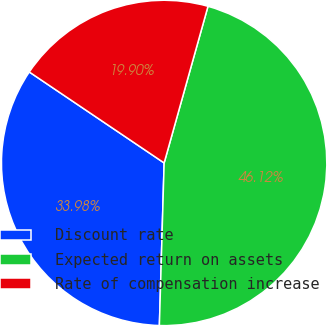Convert chart. <chart><loc_0><loc_0><loc_500><loc_500><pie_chart><fcel>Discount rate<fcel>Expected return on assets<fcel>Rate of compensation increase<nl><fcel>33.98%<fcel>46.12%<fcel>19.9%<nl></chart> 